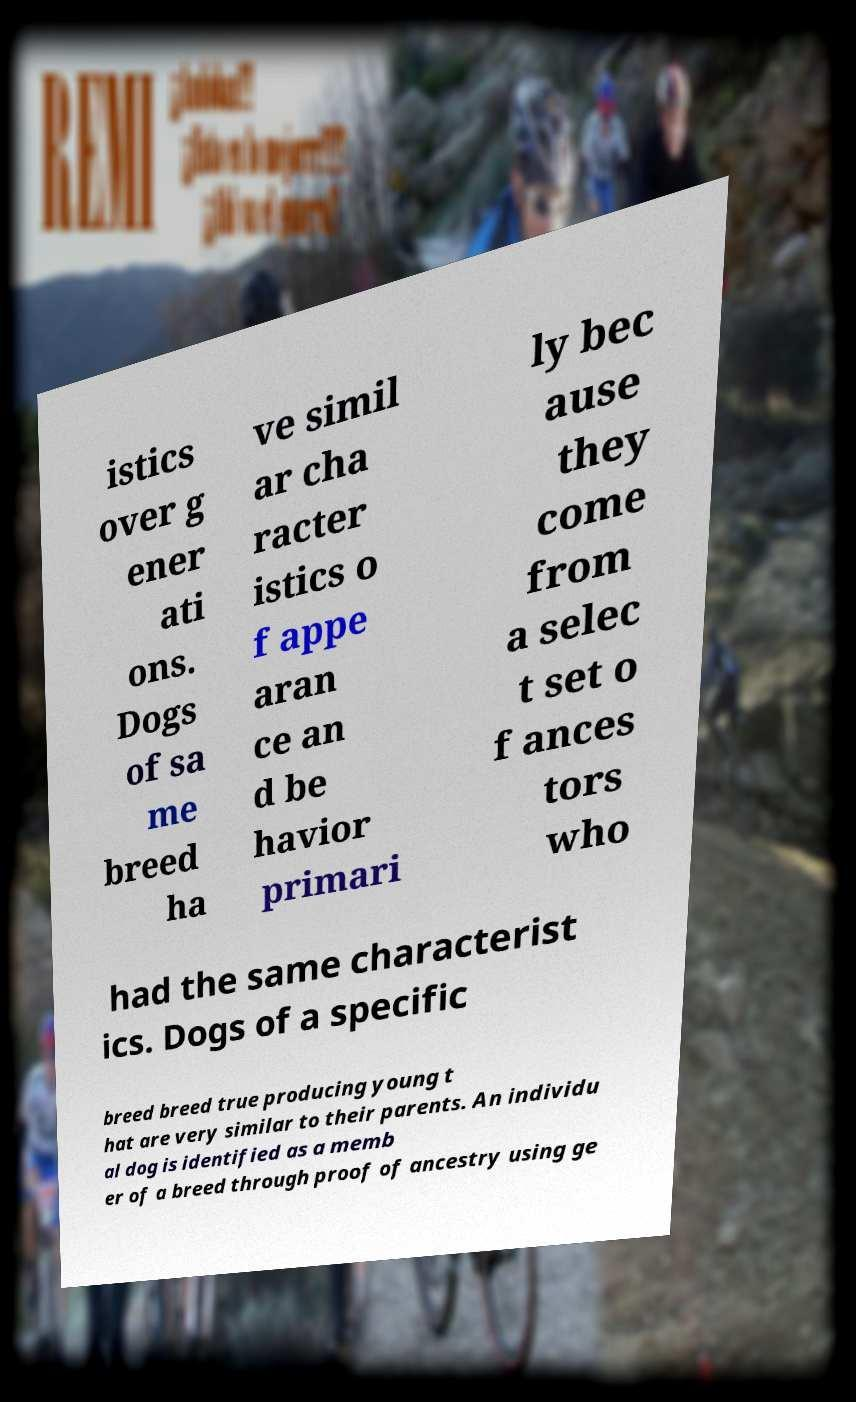Please read and relay the text visible in this image. What does it say? istics over g ener ati ons. Dogs of sa me breed ha ve simil ar cha racter istics o f appe aran ce an d be havior primari ly bec ause they come from a selec t set o f ances tors who had the same characterist ics. Dogs of a specific breed breed true producing young t hat are very similar to their parents. An individu al dog is identified as a memb er of a breed through proof of ancestry using ge 